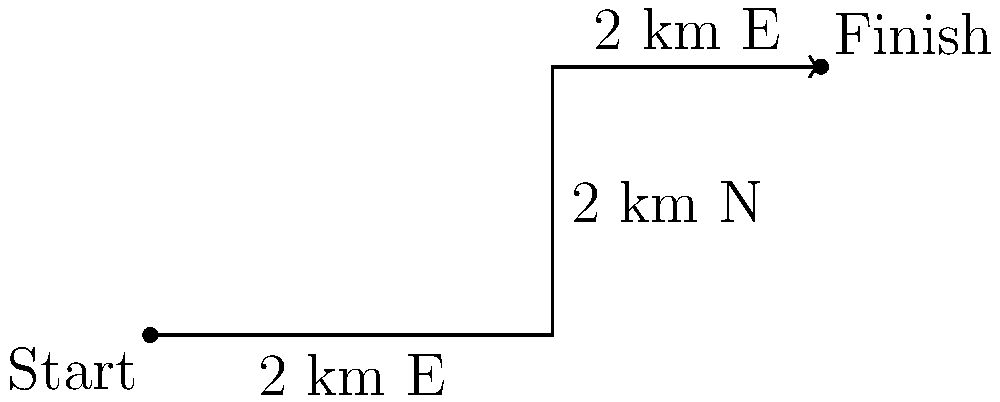During a fitness challenge, you design a route for your client that involves three consecutive segments: 2 km east, then 2 km north, and finally 2 km east again. What is the total displacement (straight-line distance) from the starting point to the finish? Let's approach this step-by-step:

1) First, we need to recognize that this is a vector addition problem. Each segment of the route is a vector, and we need to find the resultant vector.

2) Let's define our vectors:
   $\vec{v_1} = 2\hat{i}$ (2 km east)
   $\vec{v_2} = 2\hat{j}$ (2 km north)
   $\vec{v_3} = 2\hat{i}$ (2 km east)

3) The total displacement vector $\vec{D}$ is the sum of these vectors:
   $\vec{D} = \vec{v_1} + \vec{v_2} + \vec{v_3}$

4) Adding these vectors:
   $\vec{D} = (2\hat{i}) + (2\hat{j}) + (2\hat{i}) = 4\hat{i} + 2\hat{j}$

5) Now we have the displacement vector, but we need to find its magnitude (length).

6) We can use the Pythagorean theorem:
   $|\vec{D}| = \sqrt{(4)^2 + (2)^2} = \sqrt{16 + 4} = \sqrt{20}$

7) Simplify: $\sqrt{20} = 2\sqrt{5}$

Therefore, the total displacement is $2\sqrt{5}$ km.
Answer: $2\sqrt{5}$ km 